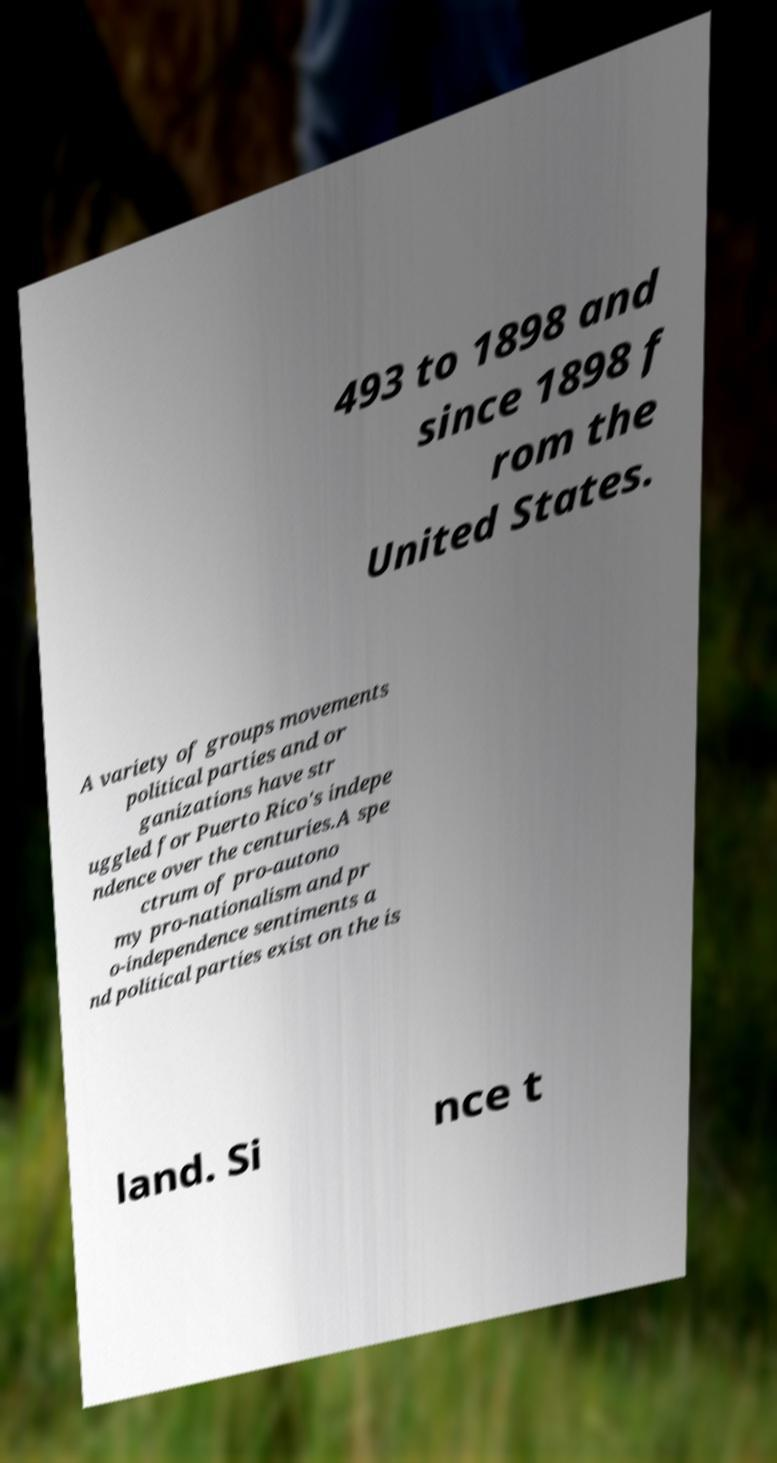What messages or text are displayed in this image? I need them in a readable, typed format. 493 to 1898 and since 1898 f rom the United States. A variety of groups movements political parties and or ganizations have str uggled for Puerto Rico's indepe ndence over the centuries.A spe ctrum of pro-autono my pro-nationalism and pr o-independence sentiments a nd political parties exist on the is land. Si nce t 